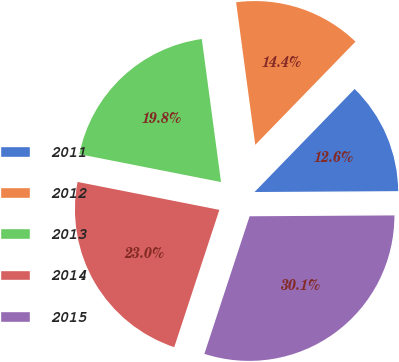Convert chart. <chart><loc_0><loc_0><loc_500><loc_500><pie_chart><fcel>2011<fcel>2012<fcel>2013<fcel>2014<fcel>2015<nl><fcel>12.64%<fcel>14.39%<fcel>19.78%<fcel>23.04%<fcel>30.15%<nl></chart> 